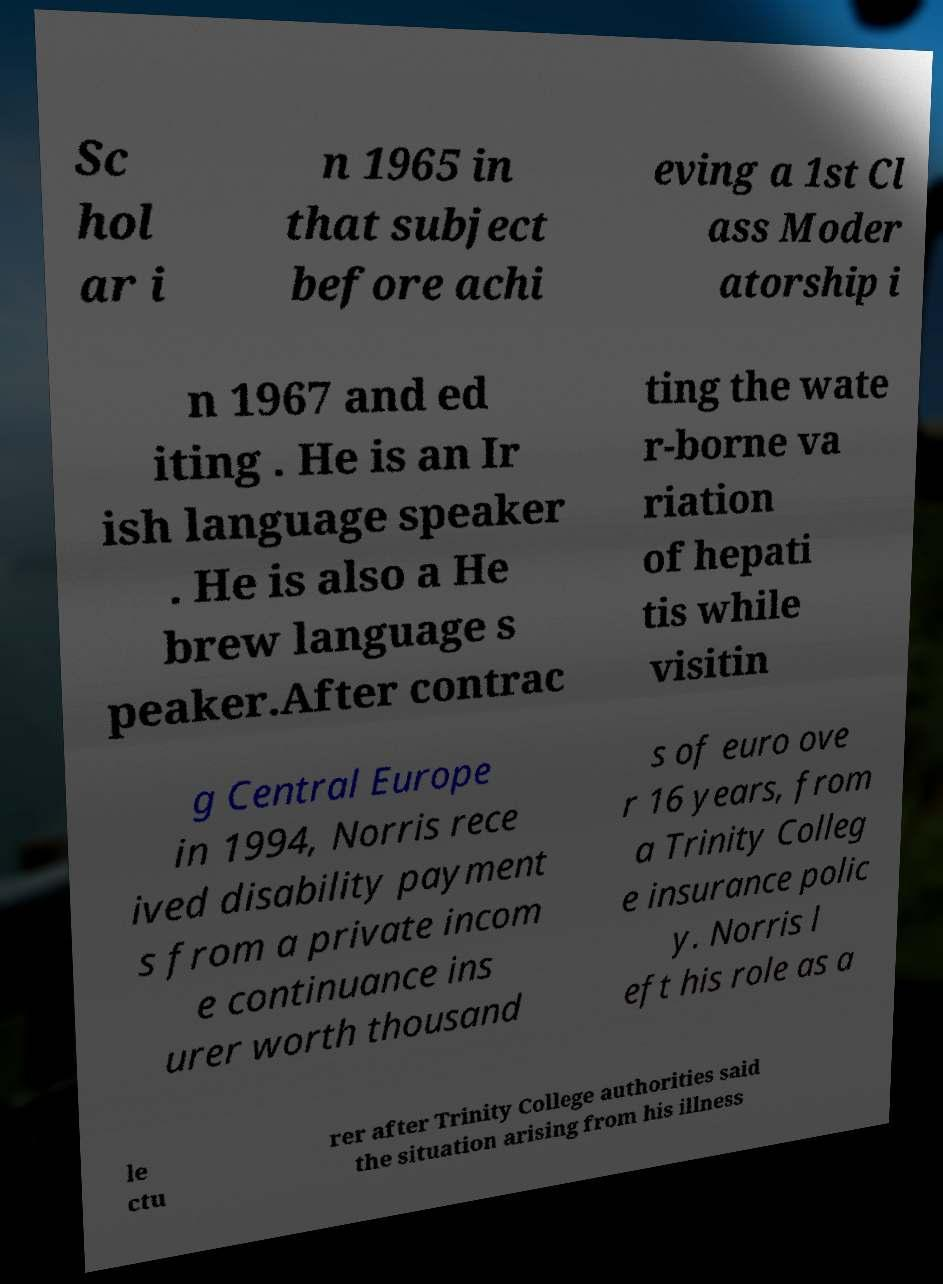What messages or text are displayed in this image? I need them in a readable, typed format. Sc hol ar i n 1965 in that subject before achi eving a 1st Cl ass Moder atorship i n 1967 and ed iting . He is an Ir ish language speaker . He is also a He brew language s peaker.After contrac ting the wate r-borne va riation of hepati tis while visitin g Central Europe in 1994, Norris rece ived disability payment s from a private incom e continuance ins urer worth thousand s of euro ove r 16 years, from a Trinity Colleg e insurance polic y. Norris l eft his role as a le ctu rer after Trinity College authorities said the situation arising from his illness 